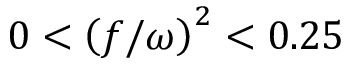<formula> <loc_0><loc_0><loc_500><loc_500>0 < \left ( f / \omega \right ) ^ { 2 } < 0 . 2 5</formula> 